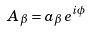<formula> <loc_0><loc_0><loc_500><loc_500>A _ { \beta } = a _ { \beta } \, e ^ { i \phi }</formula> 